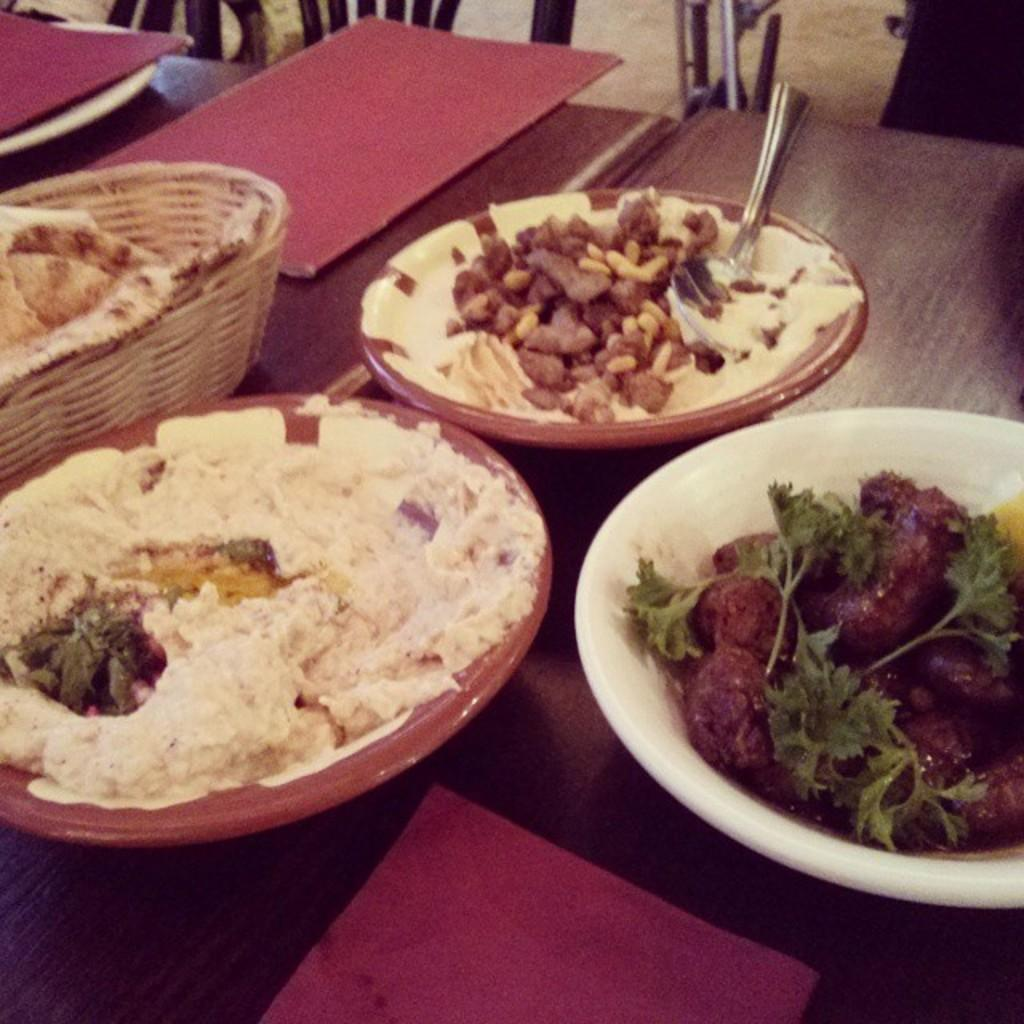What piece of furniture is present in the image? There is a table in the image. What objects are on the table? There are bowls, books, a spoon, and food items on the table. Are there any seating options near the table? Yes, there are chairs next to the table. What type of engine can be seen powering the trousers in the image? There are no trousers or engines present in the image. How many pairs of jeans are visible on the table in the image? There are no jeans present in the image. 